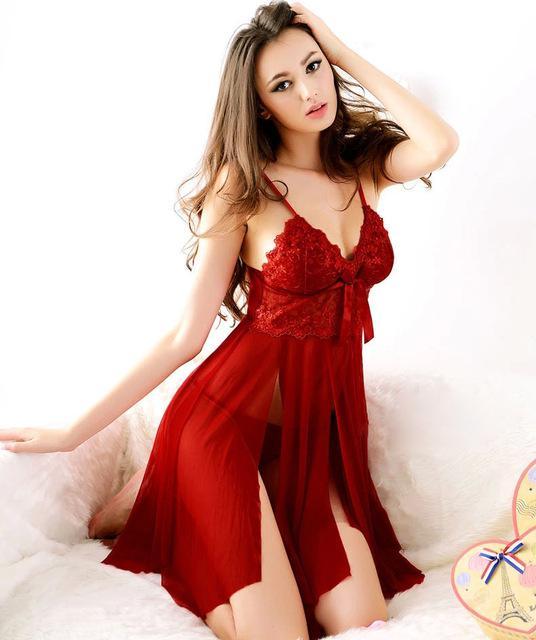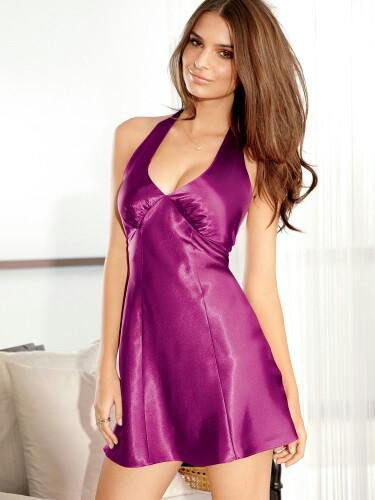The first image is the image on the left, the second image is the image on the right. Evaluate the accuracy of this statement regarding the images: "The image on the right has a model standing on her feet wearing lingerie.". Is it true? Answer yes or no. Yes. The first image is the image on the left, the second image is the image on the right. Evaluate the accuracy of this statement regarding the images: "At least one image shows a woman standing.". Is it true? Answer yes or no. Yes. 